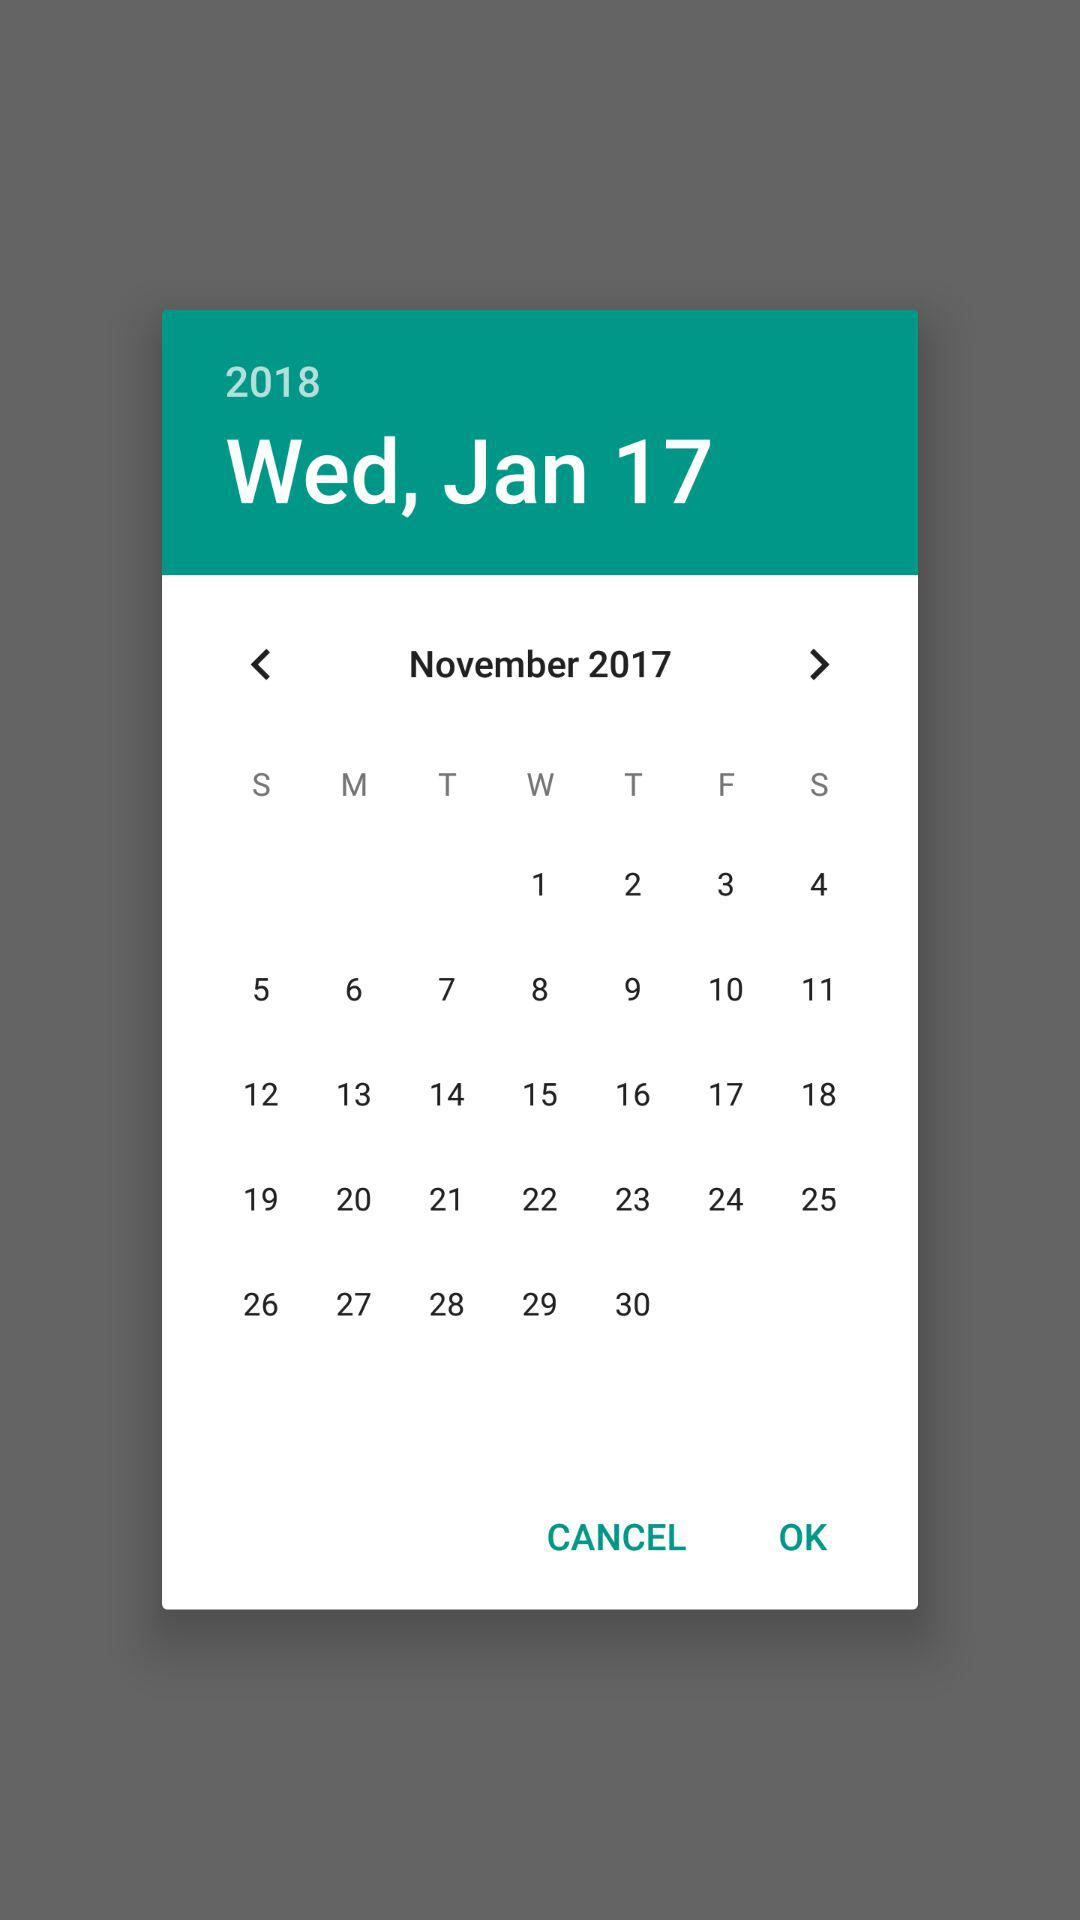What is the selected date? The selected date is Wednesday, January 17, 2018. 